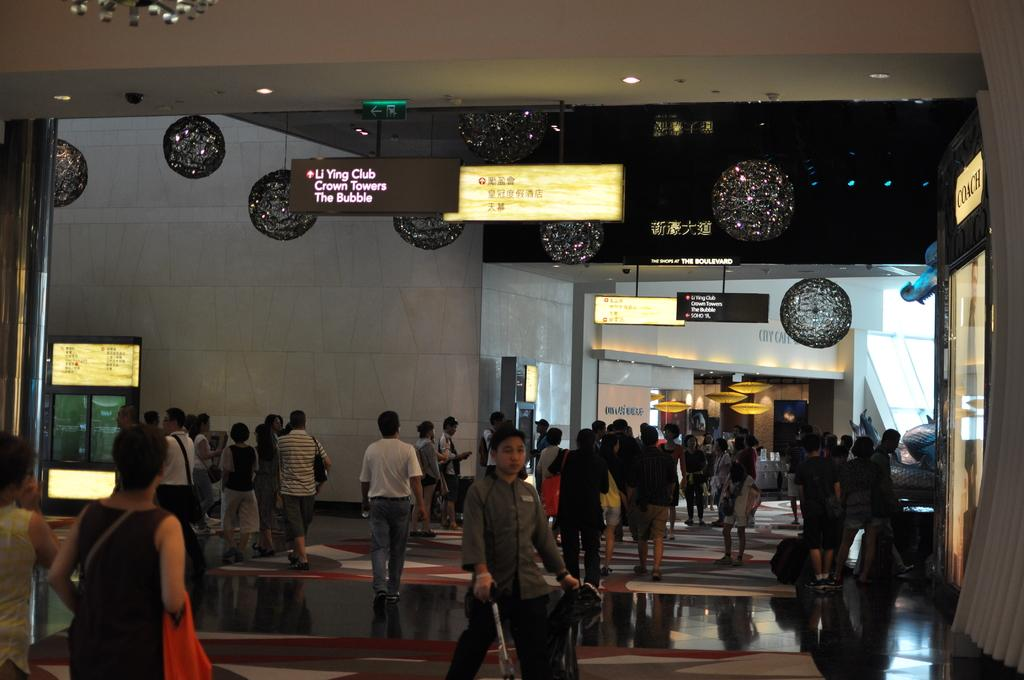How many people can be seen in the image? There are many people in the image. What can be found on the ceiling in the image? There are decorative items and boards with lights on the ceiling. What is visible in the background of the image? There are walls visible in the background of the image. Where is the goose sitting on the wall in the image? There is no goose present in the image; it only features people and decorative elements on the ceiling. 